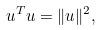<formula> <loc_0><loc_0><loc_500><loc_500>u ^ { T } u = \| u \| ^ { 2 } ,</formula> 